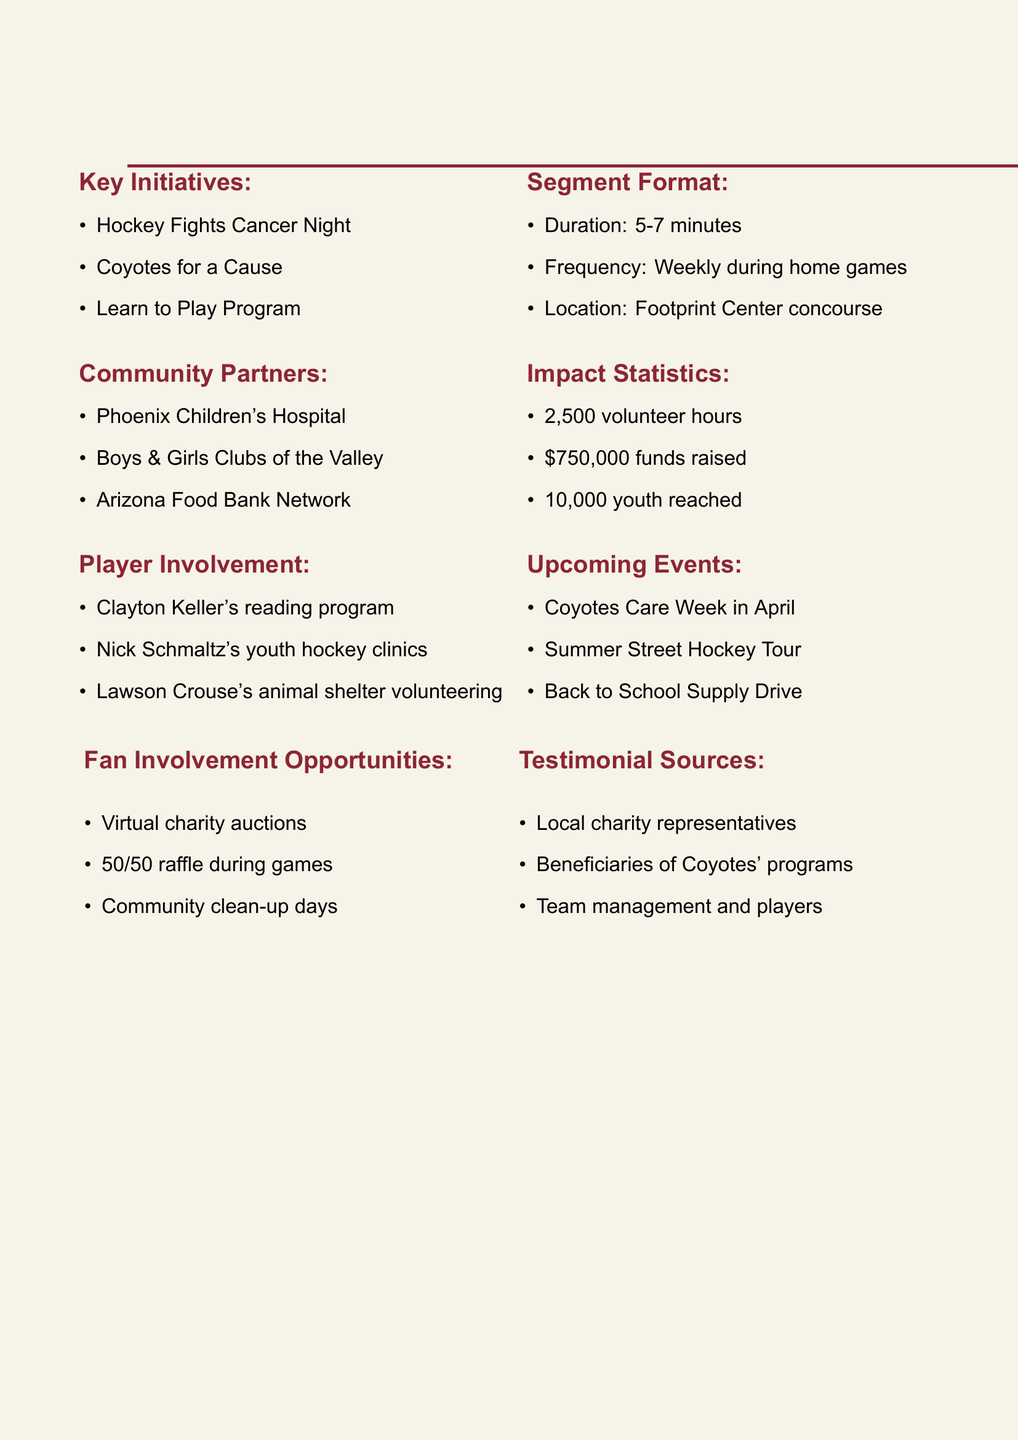what is the title of the segment? The title of the segment is the main subject highlighted in the document, which is presented at the top.
Answer: Coyotes in the Community how many volunteer hours were recorded? The document specifies a statistic regarding volunteer hours, detailing the total number reported.
Answer: 2500 which community partner focuses on children's health? One of the community partners listed has a specific focus on health services for children.
Answer: Phoenix Children's Hospital who is involved with youth hockey clinics? The document mentions individual players and their specific community involvement, including one player focusing on clinics.
Answer: Nick Schmaltz when is the Coyotes Care Week scheduled? This event is mentioned in the upcoming events section, providing a specific time in the context of the document.
Answer: April what is the location of the segment recordings? The document specifies where the segment will take place, which is essential for the broadcast setup.
Answer: Footprint Center concourse how much money was raised for community initiatives? The document reports a financial goal achieved through community initiatives, highlighting its impact.
Answer: $750,000 what type of program does Clayton Keller participate in at local schools? The document includes specific activities linked to players, detailing educational initiatives involved.
Answer: reading program how often will the segment be aired? The frequency of the segment is outlined, indicating how regularly viewers can expect to see it.
Answer: Weekly during home games 